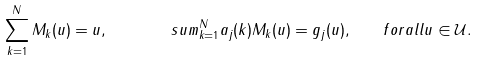Convert formula to latex. <formula><loc_0><loc_0><loc_500><loc_500>\sum _ { k = 1 } ^ { N } M _ { k } ( u ) = u , \quad \ \ \ s u m _ { k = 1 } ^ { N } a _ { j } ( k ) M _ { k } ( u ) = g _ { j } ( u ) , \quad f o r a l l u \in { \mathcal { U } } .</formula> 